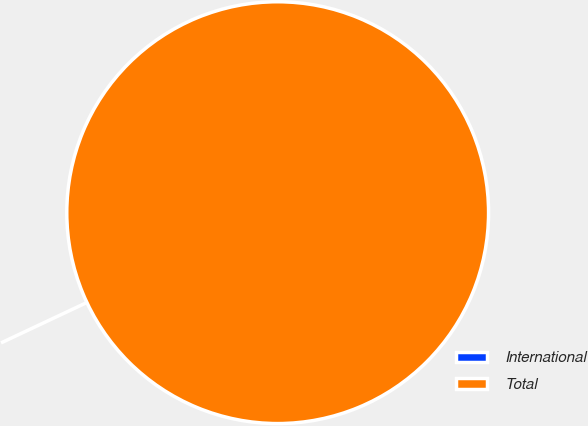Convert chart to OTSL. <chart><loc_0><loc_0><loc_500><loc_500><pie_chart><fcel>International<fcel>Total<nl><fcel>0.0%<fcel>100.0%<nl></chart> 